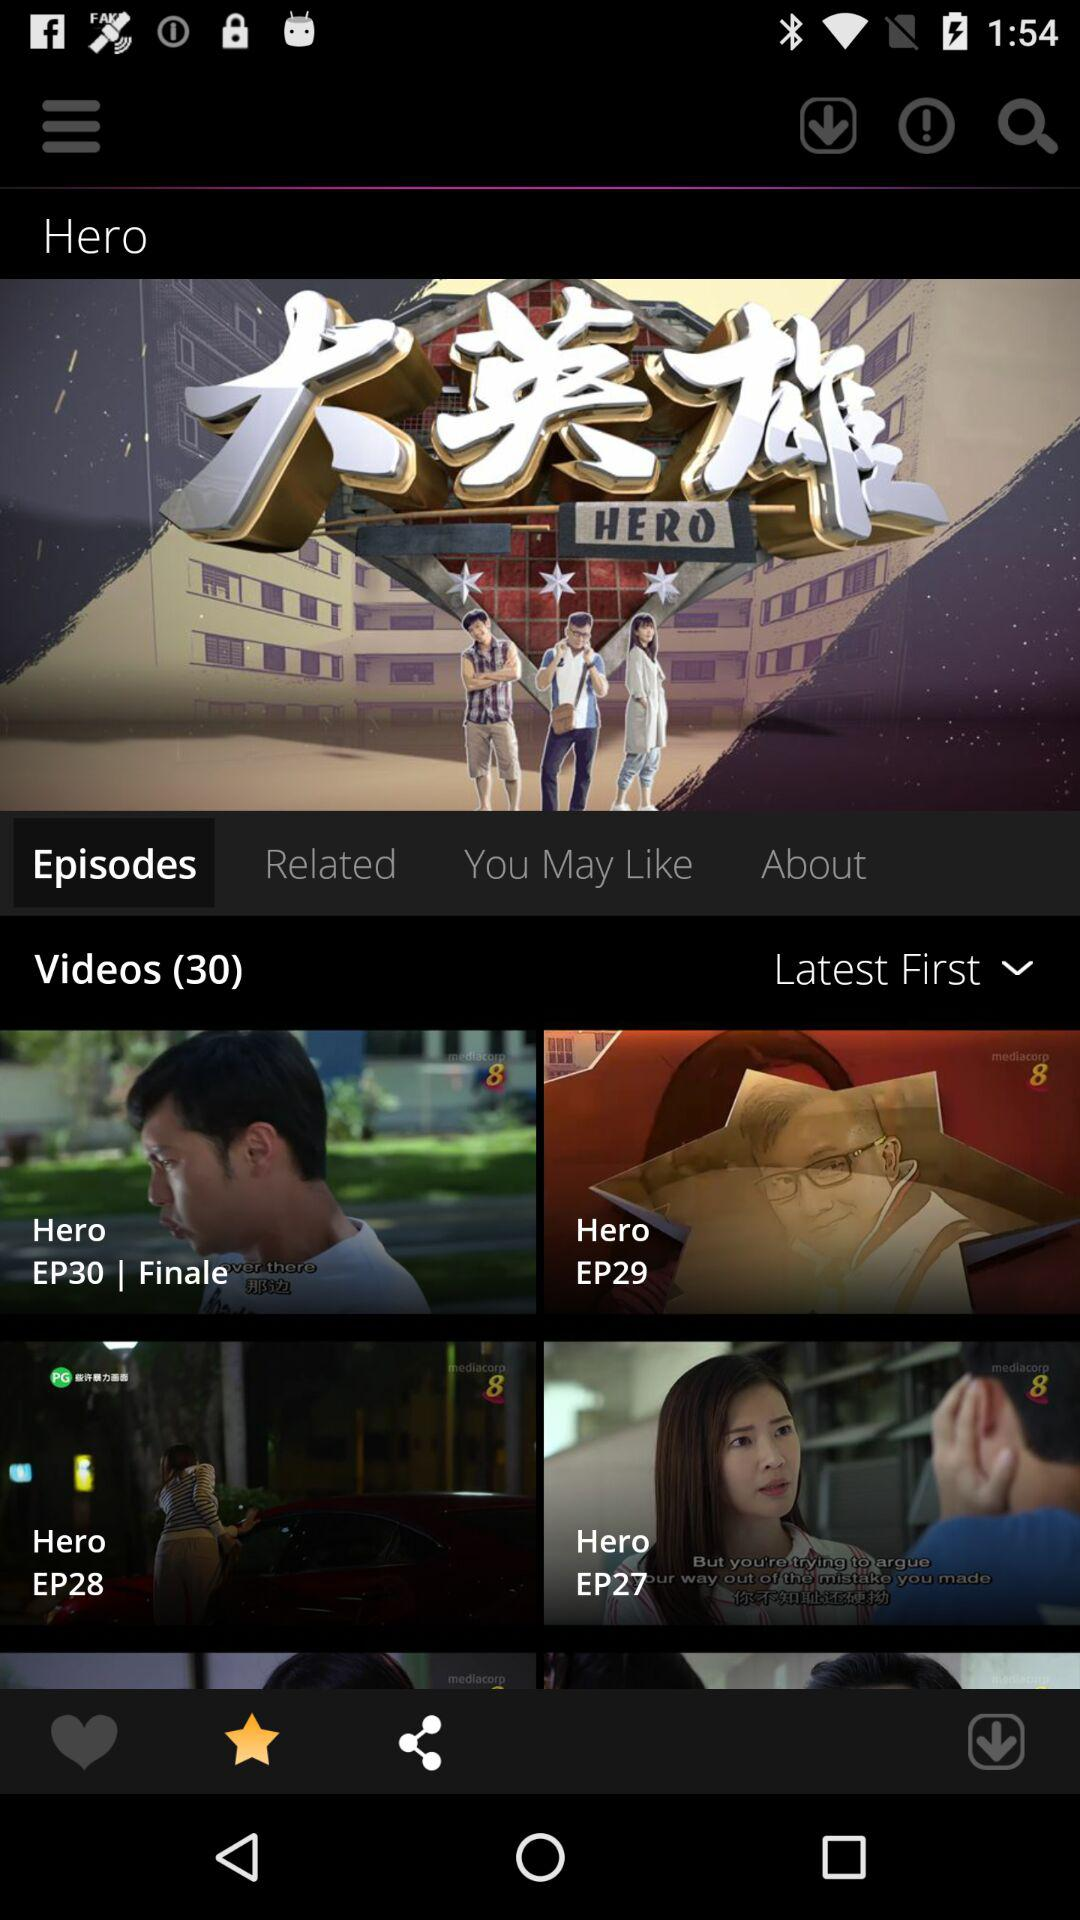How many videos are on the page?
Answer the question using a single word or phrase. 30 